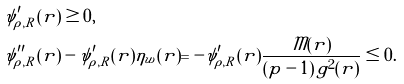<formula> <loc_0><loc_0><loc_500><loc_500>\psi ^ { \prime } _ { \rho , R } ( r ) & \geq 0 , \\ \psi ^ { \prime \prime } _ { \rho , R } ( r ) & - \psi ^ { \prime } _ { \rho , R } ( r ) \eta _ { w } ( r ) = - \psi ^ { \prime } _ { \rho , R } ( r ) \frac { \mathcal { M } ( r ) } { ( p - 1 ) \, g ^ { 2 } ( r ) } \leq 0 .</formula> 